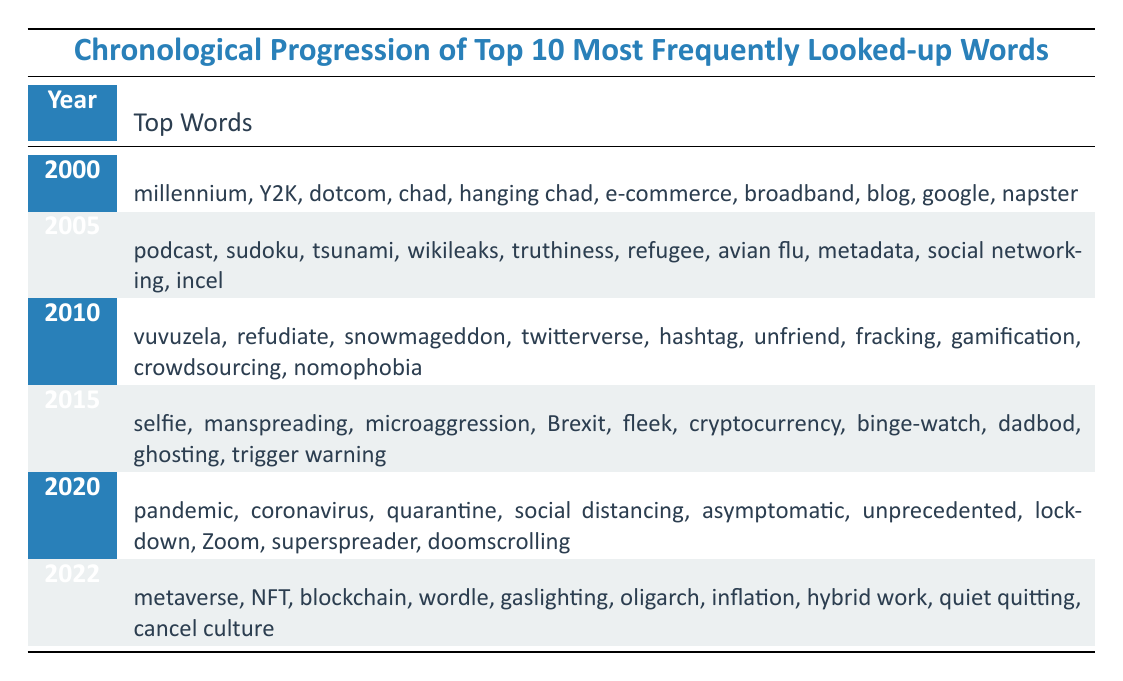What were the top look-up words in 2005? According to the table, the top look-up words in 2005 were podcast, sudoku, tsunami, wikileaks, truthiness, refugee, avian flu, metadata, social networking, and incel.
Answer: podcast, sudoku, tsunami, wikileaks, truthiness, refugee, avian flu, metadata, social networking, incel Which year saw the introduction of the word "Brexit"? The word "Brexit" appears in the list for the year 2015.
Answer: 2015 How many unique words are listed for the year 2010? There are 10 unique words listed for the year 2010: vuvuzela, refudiate, snowmageddon, twitterverse, hashtag, unfriend, fracking, gamification, crowdsourcing, and nomophobia.
Answer: 10 Did the term "zoom" appear before the year 2020? No, the term "Zoom" is listed in the year 2020, so it did not appear before that year.
Answer: No What is the difference in the themes of the top words from 2000 versus 2022? In 2000, the top words relate mainly to technology and events of that time (like millennium and Y2K), while in 2022, the words reflect newer digital concepts and societal issues (like metaverse and cancel culture). This shows an evolution from tech-focused terms to more modern cultural discussions.
Answer: Technology focus shifts to cultural issues Which year had the highest representation of social issues in the top words? 2020 had the highest representation of social issues in the top words with terms like pandemic, quarantine, social distancing, and unprecedented reflecting the global situation at that time.
Answer: 2020 List a word that was common in both 2000 and 2022 lists. There is no word that appears in both the 2000 and 2022 lists; they represent different cultural contexts and eras.
Answer: None What was the trend of technology-related terms from 2000 to 2022? The trend shows a shift from specific technology-related terms in 2000 (like broadband and e-commerce) to broadly conceptual and social technology-related terms in 2022 (like NFT and blockchain), indicating a broader integration of technology into societal contexts.
Answer: Shift to broader societal integration How many of the top words from 2015 are related to social behaviors? 5 words from 2015 are related to social behaviors: manspreading, microaggression, selfie, ghosting, and trigger warning.
Answer: 5 